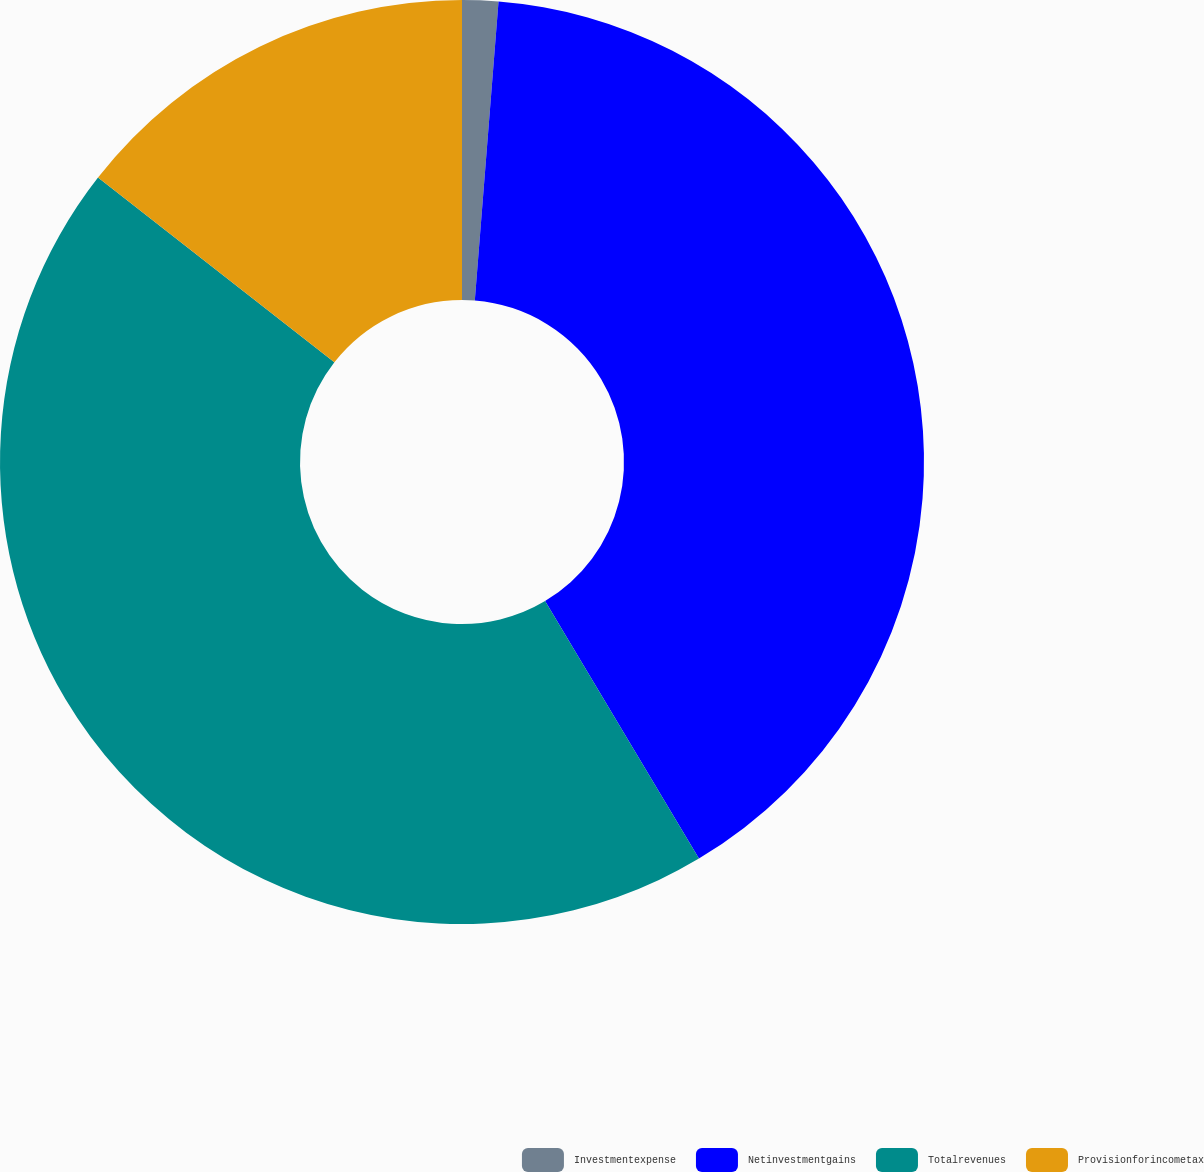Convert chart. <chart><loc_0><loc_0><loc_500><loc_500><pie_chart><fcel>Investmentexpense<fcel>Netinvestmentgains<fcel>Totalrevenues<fcel>Provisionforincometax<nl><fcel>1.26%<fcel>40.17%<fcel>44.13%<fcel>14.44%<nl></chart> 